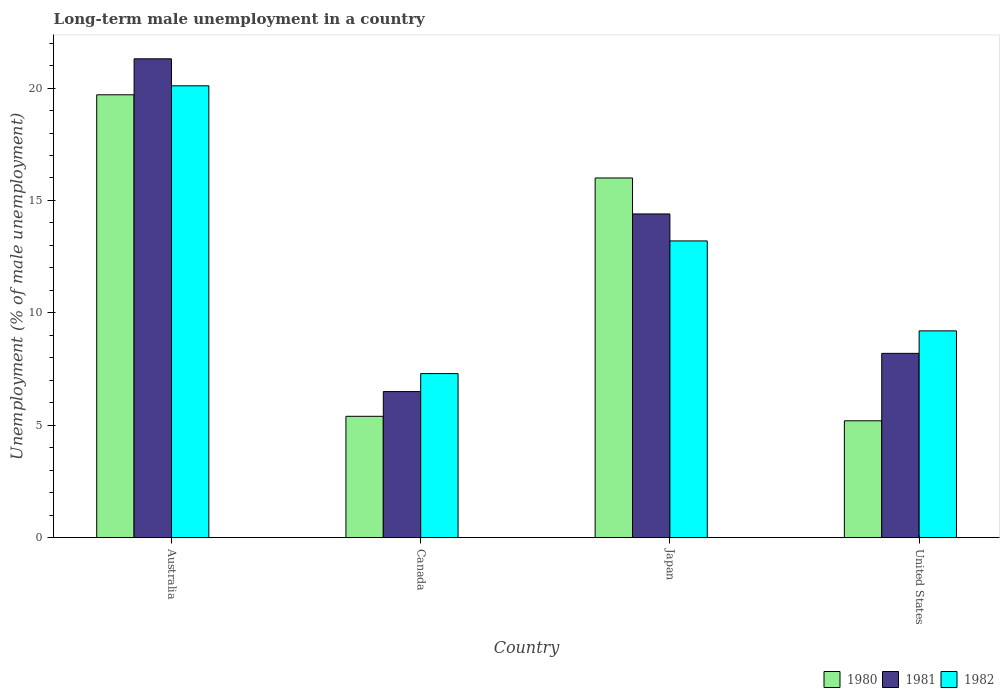How many bars are there on the 4th tick from the right?
Your response must be concise. 3. What is the label of the 4th group of bars from the left?
Provide a short and direct response. United States. In how many cases, is the number of bars for a given country not equal to the number of legend labels?
Ensure brevity in your answer.  0. What is the percentage of long-term unemployed male population in 1982 in Australia?
Your answer should be compact. 20.1. Across all countries, what is the maximum percentage of long-term unemployed male population in 1981?
Make the answer very short. 21.3. Across all countries, what is the minimum percentage of long-term unemployed male population in 1980?
Offer a very short reply. 5.2. What is the total percentage of long-term unemployed male population in 1980 in the graph?
Make the answer very short. 46.3. What is the difference between the percentage of long-term unemployed male population in 1980 in Japan and that in United States?
Offer a terse response. 10.8. What is the difference between the percentage of long-term unemployed male population in 1982 in Japan and the percentage of long-term unemployed male population in 1981 in United States?
Offer a terse response. 5. What is the average percentage of long-term unemployed male population in 1981 per country?
Give a very brief answer. 12.6. What is the difference between the percentage of long-term unemployed male population of/in 1982 and percentage of long-term unemployed male population of/in 1980 in United States?
Offer a terse response. 4. What is the ratio of the percentage of long-term unemployed male population in 1982 in Canada to that in United States?
Provide a succinct answer. 0.79. Is the percentage of long-term unemployed male population in 1980 in Japan less than that in United States?
Your answer should be compact. No. What is the difference between the highest and the second highest percentage of long-term unemployed male population in 1982?
Offer a terse response. -10.9. What is the difference between the highest and the lowest percentage of long-term unemployed male population in 1980?
Make the answer very short. 14.5. In how many countries, is the percentage of long-term unemployed male population in 1982 greater than the average percentage of long-term unemployed male population in 1982 taken over all countries?
Offer a very short reply. 2. Is the sum of the percentage of long-term unemployed male population in 1981 in Australia and United States greater than the maximum percentage of long-term unemployed male population in 1982 across all countries?
Provide a succinct answer. Yes. What does the 2nd bar from the right in Japan represents?
Provide a short and direct response. 1981. How many countries are there in the graph?
Make the answer very short. 4. Does the graph contain grids?
Offer a terse response. No. How many legend labels are there?
Your answer should be very brief. 3. What is the title of the graph?
Provide a short and direct response. Long-term male unemployment in a country. What is the label or title of the X-axis?
Give a very brief answer. Country. What is the label or title of the Y-axis?
Provide a short and direct response. Unemployment (% of male unemployment). What is the Unemployment (% of male unemployment) in 1980 in Australia?
Keep it short and to the point. 19.7. What is the Unemployment (% of male unemployment) in 1981 in Australia?
Offer a terse response. 21.3. What is the Unemployment (% of male unemployment) of 1982 in Australia?
Ensure brevity in your answer.  20.1. What is the Unemployment (% of male unemployment) in 1980 in Canada?
Keep it short and to the point. 5.4. What is the Unemployment (% of male unemployment) of 1981 in Canada?
Keep it short and to the point. 6.5. What is the Unemployment (% of male unemployment) in 1982 in Canada?
Your answer should be very brief. 7.3. What is the Unemployment (% of male unemployment) of 1981 in Japan?
Make the answer very short. 14.4. What is the Unemployment (% of male unemployment) of 1982 in Japan?
Provide a succinct answer. 13.2. What is the Unemployment (% of male unemployment) of 1980 in United States?
Offer a very short reply. 5.2. What is the Unemployment (% of male unemployment) of 1981 in United States?
Your answer should be compact. 8.2. What is the Unemployment (% of male unemployment) in 1982 in United States?
Your answer should be compact. 9.2. Across all countries, what is the maximum Unemployment (% of male unemployment) in 1980?
Offer a very short reply. 19.7. Across all countries, what is the maximum Unemployment (% of male unemployment) of 1981?
Give a very brief answer. 21.3. Across all countries, what is the maximum Unemployment (% of male unemployment) in 1982?
Offer a terse response. 20.1. Across all countries, what is the minimum Unemployment (% of male unemployment) of 1980?
Provide a short and direct response. 5.2. Across all countries, what is the minimum Unemployment (% of male unemployment) of 1981?
Your answer should be compact. 6.5. Across all countries, what is the minimum Unemployment (% of male unemployment) in 1982?
Give a very brief answer. 7.3. What is the total Unemployment (% of male unemployment) of 1980 in the graph?
Make the answer very short. 46.3. What is the total Unemployment (% of male unemployment) of 1981 in the graph?
Ensure brevity in your answer.  50.4. What is the total Unemployment (% of male unemployment) in 1982 in the graph?
Provide a short and direct response. 49.8. What is the difference between the Unemployment (% of male unemployment) of 1982 in Australia and that in Canada?
Make the answer very short. 12.8. What is the difference between the Unemployment (% of male unemployment) of 1981 in Australia and that in Japan?
Your answer should be compact. 6.9. What is the difference between the Unemployment (% of male unemployment) of 1980 in Australia and that in United States?
Keep it short and to the point. 14.5. What is the difference between the Unemployment (% of male unemployment) of 1981 in Australia and that in United States?
Give a very brief answer. 13.1. What is the difference between the Unemployment (% of male unemployment) in 1982 in Australia and that in United States?
Your answer should be compact. 10.9. What is the difference between the Unemployment (% of male unemployment) in 1981 in Canada and that in Japan?
Make the answer very short. -7.9. What is the difference between the Unemployment (% of male unemployment) in 1982 in Canada and that in Japan?
Your answer should be very brief. -5.9. What is the difference between the Unemployment (% of male unemployment) in 1980 in Canada and that in United States?
Ensure brevity in your answer.  0.2. What is the difference between the Unemployment (% of male unemployment) of 1981 in Canada and that in United States?
Provide a succinct answer. -1.7. What is the difference between the Unemployment (% of male unemployment) of 1982 in Canada and that in United States?
Ensure brevity in your answer.  -1.9. What is the difference between the Unemployment (% of male unemployment) in 1982 in Japan and that in United States?
Give a very brief answer. 4. What is the difference between the Unemployment (% of male unemployment) of 1980 in Australia and the Unemployment (% of male unemployment) of 1982 in Canada?
Keep it short and to the point. 12.4. What is the difference between the Unemployment (% of male unemployment) in 1981 in Australia and the Unemployment (% of male unemployment) in 1982 in Canada?
Keep it short and to the point. 14. What is the difference between the Unemployment (% of male unemployment) in 1980 in Australia and the Unemployment (% of male unemployment) in 1981 in Japan?
Offer a terse response. 5.3. What is the difference between the Unemployment (% of male unemployment) in 1981 in Australia and the Unemployment (% of male unemployment) in 1982 in United States?
Keep it short and to the point. 12.1. What is the difference between the Unemployment (% of male unemployment) in 1980 in Canada and the Unemployment (% of male unemployment) in 1981 in United States?
Offer a very short reply. -2.8. What is the difference between the Unemployment (% of male unemployment) of 1980 in Canada and the Unemployment (% of male unemployment) of 1982 in United States?
Ensure brevity in your answer.  -3.8. What is the difference between the Unemployment (% of male unemployment) in 1981 in Canada and the Unemployment (% of male unemployment) in 1982 in United States?
Your answer should be compact. -2.7. What is the difference between the Unemployment (% of male unemployment) in 1981 in Japan and the Unemployment (% of male unemployment) in 1982 in United States?
Keep it short and to the point. 5.2. What is the average Unemployment (% of male unemployment) of 1980 per country?
Provide a short and direct response. 11.57. What is the average Unemployment (% of male unemployment) of 1982 per country?
Offer a very short reply. 12.45. What is the difference between the Unemployment (% of male unemployment) in 1980 and Unemployment (% of male unemployment) in 1982 in Australia?
Your answer should be compact. -0.4. What is the difference between the Unemployment (% of male unemployment) in 1981 and Unemployment (% of male unemployment) in 1982 in Australia?
Your answer should be very brief. 1.2. What is the difference between the Unemployment (% of male unemployment) in 1980 and Unemployment (% of male unemployment) in 1981 in Canada?
Give a very brief answer. -1.1. What is the difference between the Unemployment (% of male unemployment) in 1980 and Unemployment (% of male unemployment) in 1982 in Canada?
Give a very brief answer. -1.9. What is the difference between the Unemployment (% of male unemployment) of 1981 and Unemployment (% of male unemployment) of 1982 in Canada?
Make the answer very short. -0.8. What is the difference between the Unemployment (% of male unemployment) of 1980 and Unemployment (% of male unemployment) of 1981 in Japan?
Provide a short and direct response. 1.6. What is the difference between the Unemployment (% of male unemployment) in 1981 and Unemployment (% of male unemployment) in 1982 in Japan?
Provide a short and direct response. 1.2. What is the ratio of the Unemployment (% of male unemployment) of 1980 in Australia to that in Canada?
Your answer should be very brief. 3.65. What is the ratio of the Unemployment (% of male unemployment) in 1981 in Australia to that in Canada?
Keep it short and to the point. 3.28. What is the ratio of the Unemployment (% of male unemployment) of 1982 in Australia to that in Canada?
Make the answer very short. 2.75. What is the ratio of the Unemployment (% of male unemployment) in 1980 in Australia to that in Japan?
Your answer should be very brief. 1.23. What is the ratio of the Unemployment (% of male unemployment) of 1981 in Australia to that in Japan?
Give a very brief answer. 1.48. What is the ratio of the Unemployment (% of male unemployment) in 1982 in Australia to that in Japan?
Give a very brief answer. 1.52. What is the ratio of the Unemployment (% of male unemployment) of 1980 in Australia to that in United States?
Provide a succinct answer. 3.79. What is the ratio of the Unemployment (% of male unemployment) of 1981 in Australia to that in United States?
Offer a very short reply. 2.6. What is the ratio of the Unemployment (% of male unemployment) of 1982 in Australia to that in United States?
Your response must be concise. 2.18. What is the ratio of the Unemployment (% of male unemployment) of 1980 in Canada to that in Japan?
Ensure brevity in your answer.  0.34. What is the ratio of the Unemployment (% of male unemployment) in 1981 in Canada to that in Japan?
Keep it short and to the point. 0.45. What is the ratio of the Unemployment (% of male unemployment) of 1982 in Canada to that in Japan?
Provide a short and direct response. 0.55. What is the ratio of the Unemployment (% of male unemployment) of 1980 in Canada to that in United States?
Make the answer very short. 1.04. What is the ratio of the Unemployment (% of male unemployment) in 1981 in Canada to that in United States?
Your answer should be very brief. 0.79. What is the ratio of the Unemployment (% of male unemployment) of 1982 in Canada to that in United States?
Provide a short and direct response. 0.79. What is the ratio of the Unemployment (% of male unemployment) in 1980 in Japan to that in United States?
Your answer should be very brief. 3.08. What is the ratio of the Unemployment (% of male unemployment) in 1981 in Japan to that in United States?
Give a very brief answer. 1.76. What is the ratio of the Unemployment (% of male unemployment) in 1982 in Japan to that in United States?
Provide a short and direct response. 1.43. What is the difference between the highest and the second highest Unemployment (% of male unemployment) of 1980?
Your answer should be compact. 3.7. What is the difference between the highest and the second highest Unemployment (% of male unemployment) in 1981?
Your answer should be compact. 6.9. What is the difference between the highest and the second highest Unemployment (% of male unemployment) of 1982?
Your answer should be compact. 6.9. What is the difference between the highest and the lowest Unemployment (% of male unemployment) of 1980?
Provide a short and direct response. 14.5. What is the difference between the highest and the lowest Unemployment (% of male unemployment) of 1981?
Give a very brief answer. 14.8. 